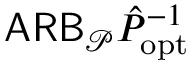Convert formula to latex. <formula><loc_0><loc_0><loc_500><loc_500>A R B _ { \mathcal { P } } \hat { P } _ { o p t } ^ { - 1 }</formula> 